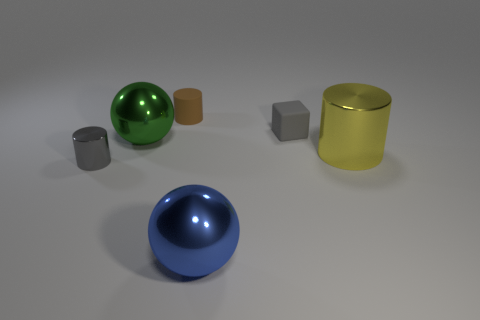Add 3 small brown metallic things. How many objects exist? 9 Subtract all balls. How many objects are left? 4 Subtract 0 red spheres. How many objects are left? 6 Subtract all tiny gray shiny things. Subtract all gray cubes. How many objects are left? 4 Add 1 gray matte objects. How many gray matte objects are left? 2 Add 4 big green things. How many big green things exist? 5 